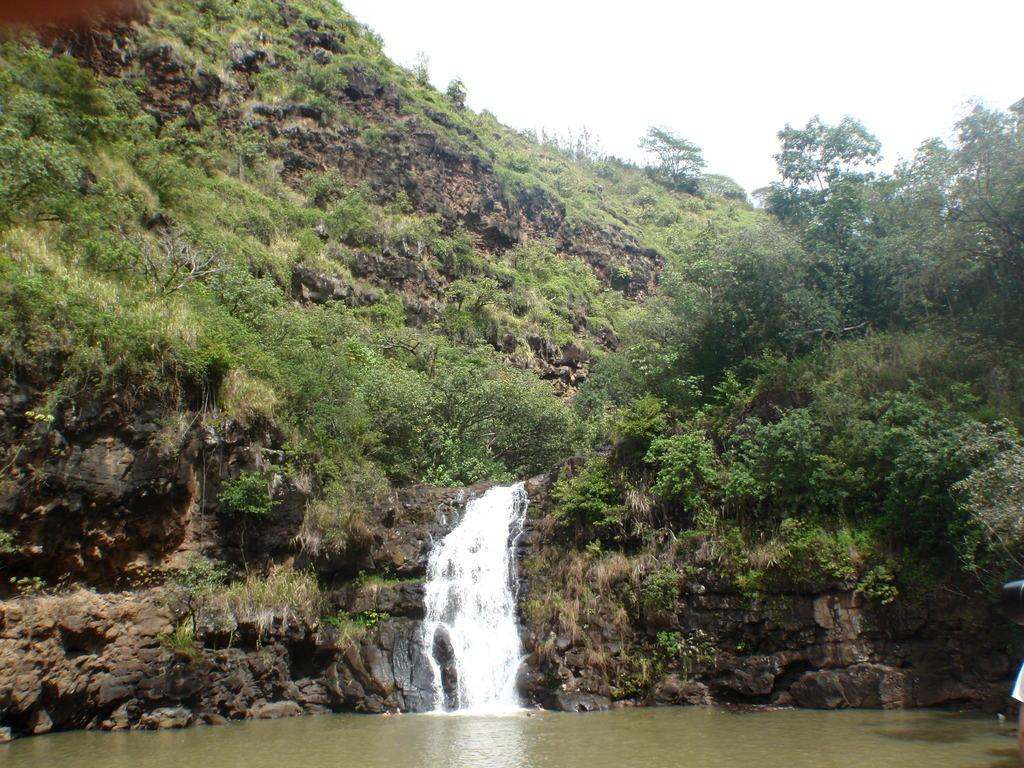What type of vegetation can be seen in the image? There are trees and plants visible in the image. What else is present in the image besides vegetation? There is water visible in the image. What can be seen in the background of the image? The sky is visible in the background of the image. What type of bread is being served to the queen in the image? There is no bread or queen present in the image. 